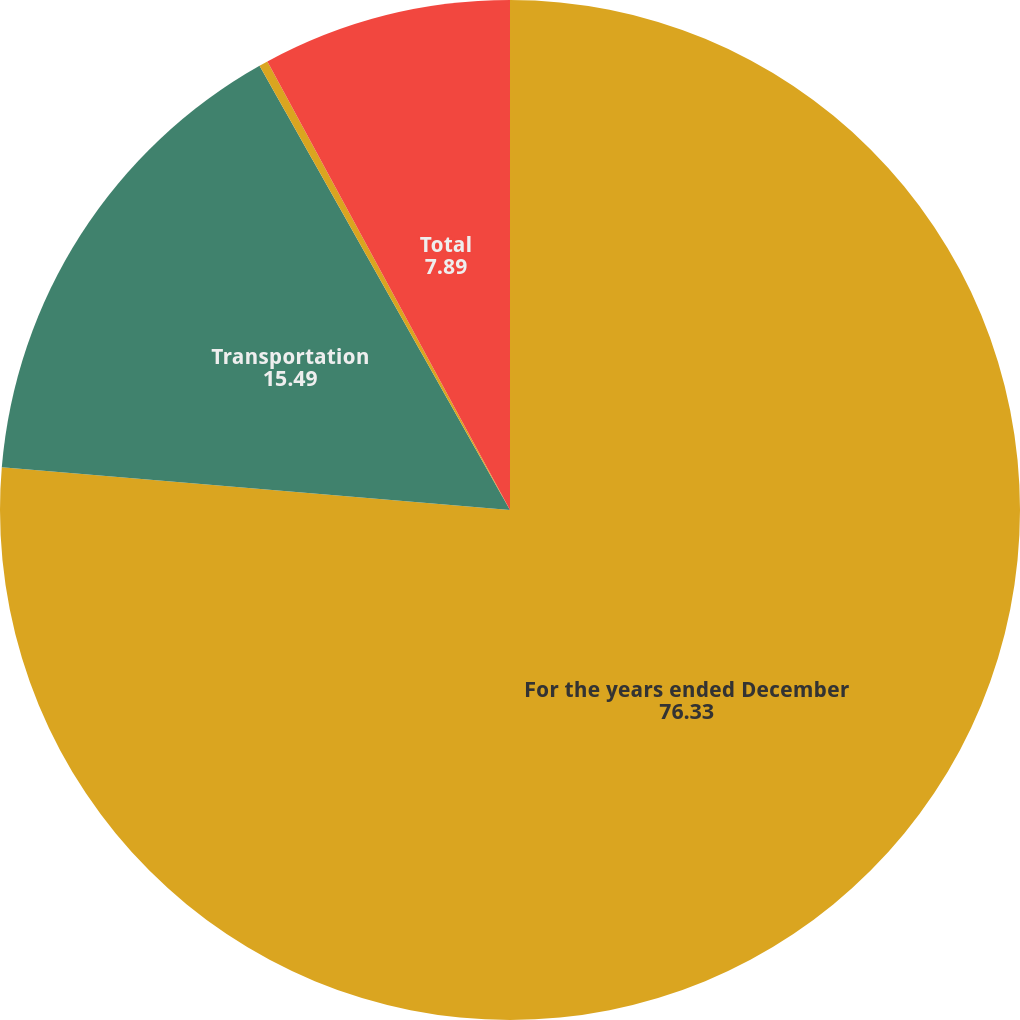Convert chart to OTSL. <chart><loc_0><loc_0><loc_500><loc_500><pie_chart><fcel>For the years ended December<fcel>Transportation<fcel>Sourcing<fcel>Total<nl><fcel>76.33%<fcel>15.49%<fcel>0.28%<fcel>7.89%<nl></chart> 